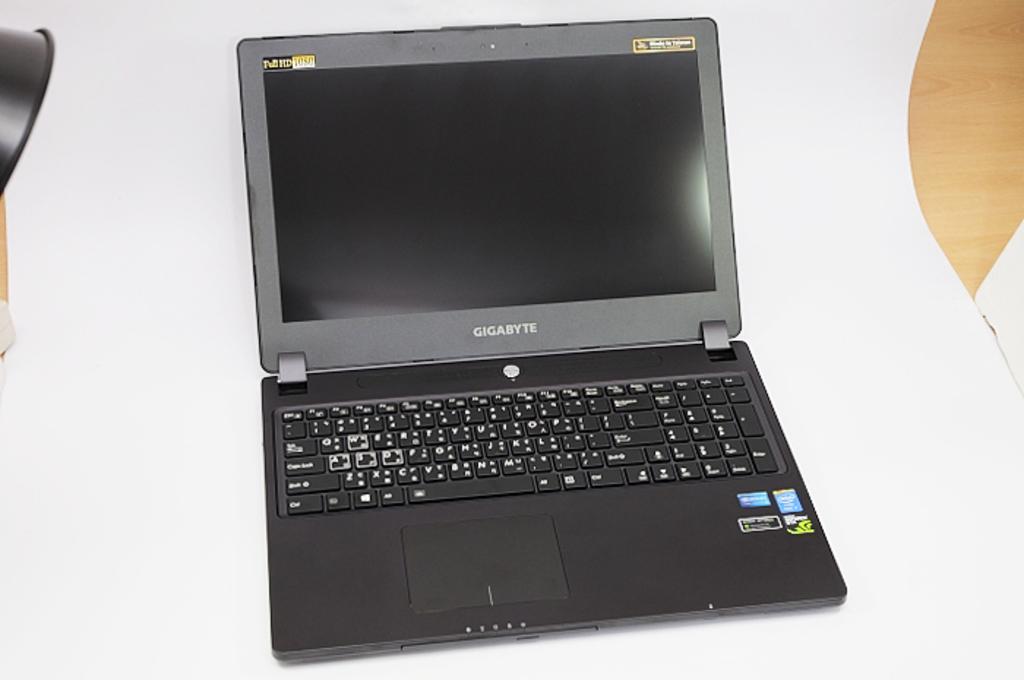What brand of laptop is this?
Offer a very short reply. Gigabyte. What color is the brand name?
Provide a short and direct response. White. 